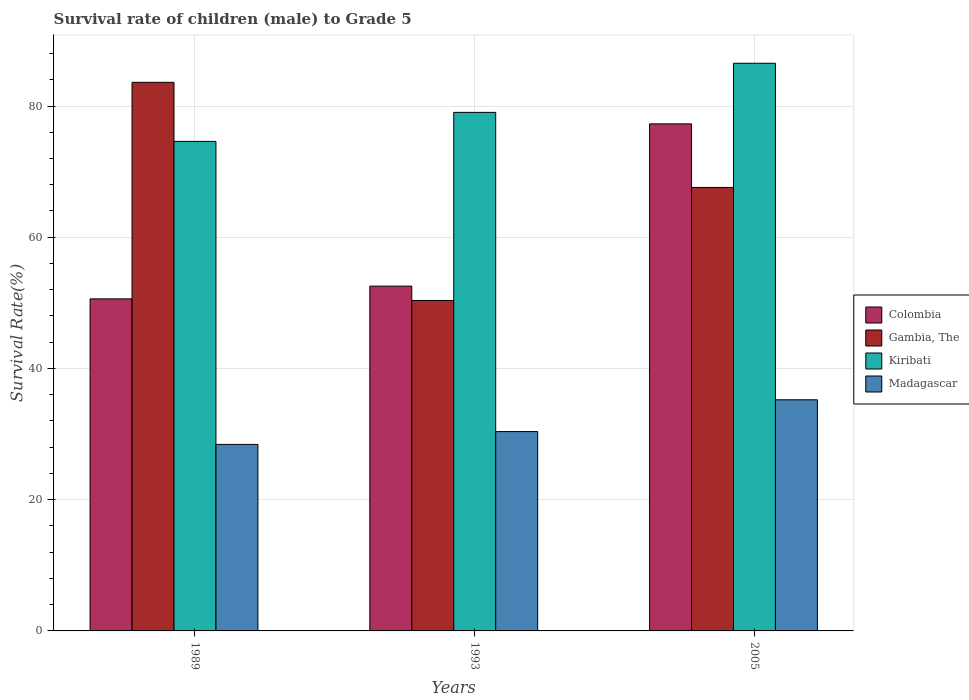How many different coloured bars are there?
Offer a very short reply. 4. How many groups of bars are there?
Give a very brief answer. 3. What is the survival rate of male children to grade 5 in Madagascar in 2005?
Your answer should be very brief. 35.23. Across all years, what is the maximum survival rate of male children to grade 5 in Madagascar?
Offer a very short reply. 35.23. Across all years, what is the minimum survival rate of male children to grade 5 in Madagascar?
Make the answer very short. 28.43. In which year was the survival rate of male children to grade 5 in Madagascar maximum?
Provide a short and direct response. 2005. What is the total survival rate of male children to grade 5 in Gambia, The in the graph?
Provide a succinct answer. 201.56. What is the difference between the survival rate of male children to grade 5 in Madagascar in 1989 and that in 1993?
Offer a terse response. -1.96. What is the difference between the survival rate of male children to grade 5 in Gambia, The in 1993 and the survival rate of male children to grade 5 in Madagascar in 2005?
Your answer should be very brief. 15.14. What is the average survival rate of male children to grade 5 in Madagascar per year?
Your response must be concise. 31.35. In the year 1989, what is the difference between the survival rate of male children to grade 5 in Colombia and survival rate of male children to grade 5 in Madagascar?
Give a very brief answer. 22.18. What is the ratio of the survival rate of male children to grade 5 in Kiribati in 1993 to that in 2005?
Your response must be concise. 0.91. Is the difference between the survival rate of male children to grade 5 in Colombia in 1989 and 1993 greater than the difference between the survival rate of male children to grade 5 in Madagascar in 1989 and 1993?
Give a very brief answer. Yes. What is the difference between the highest and the second highest survival rate of male children to grade 5 in Colombia?
Your answer should be compact. 24.73. What is the difference between the highest and the lowest survival rate of male children to grade 5 in Madagascar?
Keep it short and to the point. 6.8. In how many years, is the survival rate of male children to grade 5 in Kiribati greater than the average survival rate of male children to grade 5 in Kiribati taken over all years?
Ensure brevity in your answer.  1. Is the sum of the survival rate of male children to grade 5 in Madagascar in 1989 and 2005 greater than the maximum survival rate of male children to grade 5 in Colombia across all years?
Offer a terse response. No. Is it the case that in every year, the sum of the survival rate of male children to grade 5 in Madagascar and survival rate of male children to grade 5 in Colombia is greater than the sum of survival rate of male children to grade 5 in Kiribati and survival rate of male children to grade 5 in Gambia, The?
Provide a succinct answer. Yes. What does the 2nd bar from the left in 2005 represents?
Provide a short and direct response. Gambia, The. What does the 1st bar from the right in 1989 represents?
Ensure brevity in your answer.  Madagascar. Are all the bars in the graph horizontal?
Your answer should be compact. No. How many years are there in the graph?
Keep it short and to the point. 3. Are the values on the major ticks of Y-axis written in scientific E-notation?
Provide a succinct answer. No. How many legend labels are there?
Give a very brief answer. 4. What is the title of the graph?
Give a very brief answer. Survival rate of children (male) to Grade 5. Does "Botswana" appear as one of the legend labels in the graph?
Your answer should be compact. No. What is the label or title of the X-axis?
Make the answer very short. Years. What is the label or title of the Y-axis?
Offer a terse response. Survival Rate(%). What is the Survival Rate(%) of Colombia in 1989?
Make the answer very short. 50.61. What is the Survival Rate(%) of Gambia, The in 1989?
Provide a short and direct response. 83.61. What is the Survival Rate(%) in Kiribati in 1989?
Make the answer very short. 74.61. What is the Survival Rate(%) of Madagascar in 1989?
Ensure brevity in your answer.  28.43. What is the Survival Rate(%) in Colombia in 1993?
Ensure brevity in your answer.  52.55. What is the Survival Rate(%) of Gambia, The in 1993?
Provide a succinct answer. 50.36. What is the Survival Rate(%) in Kiribati in 1993?
Provide a succinct answer. 79.03. What is the Survival Rate(%) in Madagascar in 1993?
Make the answer very short. 30.38. What is the Survival Rate(%) of Colombia in 2005?
Offer a terse response. 77.28. What is the Survival Rate(%) of Gambia, The in 2005?
Offer a very short reply. 67.59. What is the Survival Rate(%) of Kiribati in 2005?
Your answer should be very brief. 86.52. What is the Survival Rate(%) of Madagascar in 2005?
Offer a very short reply. 35.23. Across all years, what is the maximum Survival Rate(%) in Colombia?
Give a very brief answer. 77.28. Across all years, what is the maximum Survival Rate(%) of Gambia, The?
Give a very brief answer. 83.61. Across all years, what is the maximum Survival Rate(%) of Kiribati?
Your response must be concise. 86.52. Across all years, what is the maximum Survival Rate(%) of Madagascar?
Keep it short and to the point. 35.23. Across all years, what is the minimum Survival Rate(%) of Colombia?
Provide a short and direct response. 50.61. Across all years, what is the minimum Survival Rate(%) of Gambia, The?
Offer a terse response. 50.36. Across all years, what is the minimum Survival Rate(%) of Kiribati?
Offer a terse response. 74.61. Across all years, what is the minimum Survival Rate(%) in Madagascar?
Provide a short and direct response. 28.43. What is the total Survival Rate(%) in Colombia in the graph?
Offer a terse response. 180.44. What is the total Survival Rate(%) in Gambia, The in the graph?
Keep it short and to the point. 201.56. What is the total Survival Rate(%) in Kiribati in the graph?
Ensure brevity in your answer.  240.15. What is the total Survival Rate(%) of Madagascar in the graph?
Ensure brevity in your answer.  94.04. What is the difference between the Survival Rate(%) in Colombia in 1989 and that in 1993?
Your answer should be compact. -1.94. What is the difference between the Survival Rate(%) in Gambia, The in 1989 and that in 1993?
Offer a terse response. 33.25. What is the difference between the Survival Rate(%) of Kiribati in 1989 and that in 1993?
Keep it short and to the point. -4.42. What is the difference between the Survival Rate(%) of Madagascar in 1989 and that in 1993?
Your answer should be very brief. -1.96. What is the difference between the Survival Rate(%) of Colombia in 1989 and that in 2005?
Keep it short and to the point. -26.67. What is the difference between the Survival Rate(%) of Gambia, The in 1989 and that in 2005?
Give a very brief answer. 16.02. What is the difference between the Survival Rate(%) of Kiribati in 1989 and that in 2005?
Your answer should be compact. -11.91. What is the difference between the Survival Rate(%) in Madagascar in 1989 and that in 2005?
Offer a terse response. -6.8. What is the difference between the Survival Rate(%) in Colombia in 1993 and that in 2005?
Offer a terse response. -24.73. What is the difference between the Survival Rate(%) of Gambia, The in 1993 and that in 2005?
Offer a very short reply. -17.23. What is the difference between the Survival Rate(%) in Kiribati in 1993 and that in 2005?
Provide a succinct answer. -7.49. What is the difference between the Survival Rate(%) in Madagascar in 1993 and that in 2005?
Provide a short and direct response. -4.84. What is the difference between the Survival Rate(%) of Colombia in 1989 and the Survival Rate(%) of Gambia, The in 1993?
Offer a terse response. 0.25. What is the difference between the Survival Rate(%) in Colombia in 1989 and the Survival Rate(%) in Kiribati in 1993?
Your response must be concise. -28.42. What is the difference between the Survival Rate(%) in Colombia in 1989 and the Survival Rate(%) in Madagascar in 1993?
Your answer should be compact. 20.22. What is the difference between the Survival Rate(%) in Gambia, The in 1989 and the Survival Rate(%) in Kiribati in 1993?
Provide a succinct answer. 4.58. What is the difference between the Survival Rate(%) in Gambia, The in 1989 and the Survival Rate(%) in Madagascar in 1993?
Offer a terse response. 53.23. What is the difference between the Survival Rate(%) in Kiribati in 1989 and the Survival Rate(%) in Madagascar in 1993?
Give a very brief answer. 44.22. What is the difference between the Survival Rate(%) in Colombia in 1989 and the Survival Rate(%) in Gambia, The in 2005?
Offer a very short reply. -16.98. What is the difference between the Survival Rate(%) of Colombia in 1989 and the Survival Rate(%) of Kiribati in 2005?
Keep it short and to the point. -35.91. What is the difference between the Survival Rate(%) of Colombia in 1989 and the Survival Rate(%) of Madagascar in 2005?
Give a very brief answer. 15.38. What is the difference between the Survival Rate(%) in Gambia, The in 1989 and the Survival Rate(%) in Kiribati in 2005?
Keep it short and to the point. -2.91. What is the difference between the Survival Rate(%) in Gambia, The in 1989 and the Survival Rate(%) in Madagascar in 2005?
Your answer should be compact. 48.39. What is the difference between the Survival Rate(%) of Kiribati in 1989 and the Survival Rate(%) of Madagascar in 2005?
Provide a succinct answer. 39.38. What is the difference between the Survival Rate(%) of Colombia in 1993 and the Survival Rate(%) of Gambia, The in 2005?
Your answer should be very brief. -15.04. What is the difference between the Survival Rate(%) in Colombia in 1993 and the Survival Rate(%) in Kiribati in 2005?
Your response must be concise. -33.97. What is the difference between the Survival Rate(%) in Colombia in 1993 and the Survival Rate(%) in Madagascar in 2005?
Provide a succinct answer. 17.32. What is the difference between the Survival Rate(%) in Gambia, The in 1993 and the Survival Rate(%) in Kiribati in 2005?
Provide a short and direct response. -36.15. What is the difference between the Survival Rate(%) in Gambia, The in 1993 and the Survival Rate(%) in Madagascar in 2005?
Make the answer very short. 15.14. What is the difference between the Survival Rate(%) in Kiribati in 1993 and the Survival Rate(%) in Madagascar in 2005?
Offer a very short reply. 43.8. What is the average Survival Rate(%) in Colombia per year?
Ensure brevity in your answer.  60.15. What is the average Survival Rate(%) in Gambia, The per year?
Offer a terse response. 67.19. What is the average Survival Rate(%) of Kiribati per year?
Offer a very short reply. 80.05. What is the average Survival Rate(%) of Madagascar per year?
Ensure brevity in your answer.  31.35. In the year 1989, what is the difference between the Survival Rate(%) in Colombia and Survival Rate(%) in Gambia, The?
Your response must be concise. -33. In the year 1989, what is the difference between the Survival Rate(%) of Colombia and Survival Rate(%) of Kiribati?
Provide a succinct answer. -24. In the year 1989, what is the difference between the Survival Rate(%) of Colombia and Survival Rate(%) of Madagascar?
Ensure brevity in your answer.  22.18. In the year 1989, what is the difference between the Survival Rate(%) in Gambia, The and Survival Rate(%) in Kiribati?
Offer a very short reply. 9. In the year 1989, what is the difference between the Survival Rate(%) of Gambia, The and Survival Rate(%) of Madagascar?
Provide a short and direct response. 55.18. In the year 1989, what is the difference between the Survival Rate(%) in Kiribati and Survival Rate(%) in Madagascar?
Your response must be concise. 46.18. In the year 1993, what is the difference between the Survival Rate(%) in Colombia and Survival Rate(%) in Gambia, The?
Offer a terse response. 2.19. In the year 1993, what is the difference between the Survival Rate(%) of Colombia and Survival Rate(%) of Kiribati?
Provide a short and direct response. -26.48. In the year 1993, what is the difference between the Survival Rate(%) of Colombia and Survival Rate(%) of Madagascar?
Give a very brief answer. 22.16. In the year 1993, what is the difference between the Survival Rate(%) of Gambia, The and Survival Rate(%) of Kiribati?
Keep it short and to the point. -28.67. In the year 1993, what is the difference between the Survival Rate(%) in Gambia, The and Survival Rate(%) in Madagascar?
Provide a short and direct response. 19.98. In the year 1993, what is the difference between the Survival Rate(%) of Kiribati and Survival Rate(%) of Madagascar?
Provide a succinct answer. 48.64. In the year 2005, what is the difference between the Survival Rate(%) in Colombia and Survival Rate(%) in Gambia, The?
Give a very brief answer. 9.69. In the year 2005, what is the difference between the Survival Rate(%) of Colombia and Survival Rate(%) of Kiribati?
Offer a terse response. -9.24. In the year 2005, what is the difference between the Survival Rate(%) of Colombia and Survival Rate(%) of Madagascar?
Offer a terse response. 42.05. In the year 2005, what is the difference between the Survival Rate(%) in Gambia, The and Survival Rate(%) in Kiribati?
Offer a terse response. -18.93. In the year 2005, what is the difference between the Survival Rate(%) of Gambia, The and Survival Rate(%) of Madagascar?
Offer a very short reply. 32.36. In the year 2005, what is the difference between the Survival Rate(%) in Kiribati and Survival Rate(%) in Madagascar?
Your answer should be compact. 51.29. What is the ratio of the Survival Rate(%) in Colombia in 1989 to that in 1993?
Provide a succinct answer. 0.96. What is the ratio of the Survival Rate(%) of Gambia, The in 1989 to that in 1993?
Make the answer very short. 1.66. What is the ratio of the Survival Rate(%) of Kiribati in 1989 to that in 1993?
Offer a very short reply. 0.94. What is the ratio of the Survival Rate(%) of Madagascar in 1989 to that in 1993?
Give a very brief answer. 0.94. What is the ratio of the Survival Rate(%) of Colombia in 1989 to that in 2005?
Provide a short and direct response. 0.65. What is the ratio of the Survival Rate(%) of Gambia, The in 1989 to that in 2005?
Give a very brief answer. 1.24. What is the ratio of the Survival Rate(%) in Kiribati in 1989 to that in 2005?
Offer a terse response. 0.86. What is the ratio of the Survival Rate(%) of Madagascar in 1989 to that in 2005?
Your response must be concise. 0.81. What is the ratio of the Survival Rate(%) of Colombia in 1993 to that in 2005?
Provide a short and direct response. 0.68. What is the ratio of the Survival Rate(%) in Gambia, The in 1993 to that in 2005?
Provide a succinct answer. 0.75. What is the ratio of the Survival Rate(%) of Kiribati in 1993 to that in 2005?
Provide a short and direct response. 0.91. What is the ratio of the Survival Rate(%) in Madagascar in 1993 to that in 2005?
Your answer should be very brief. 0.86. What is the difference between the highest and the second highest Survival Rate(%) of Colombia?
Your response must be concise. 24.73. What is the difference between the highest and the second highest Survival Rate(%) in Gambia, The?
Your answer should be very brief. 16.02. What is the difference between the highest and the second highest Survival Rate(%) of Kiribati?
Offer a terse response. 7.49. What is the difference between the highest and the second highest Survival Rate(%) of Madagascar?
Your response must be concise. 4.84. What is the difference between the highest and the lowest Survival Rate(%) in Colombia?
Give a very brief answer. 26.67. What is the difference between the highest and the lowest Survival Rate(%) of Gambia, The?
Provide a succinct answer. 33.25. What is the difference between the highest and the lowest Survival Rate(%) in Kiribati?
Provide a short and direct response. 11.91. What is the difference between the highest and the lowest Survival Rate(%) in Madagascar?
Offer a very short reply. 6.8. 